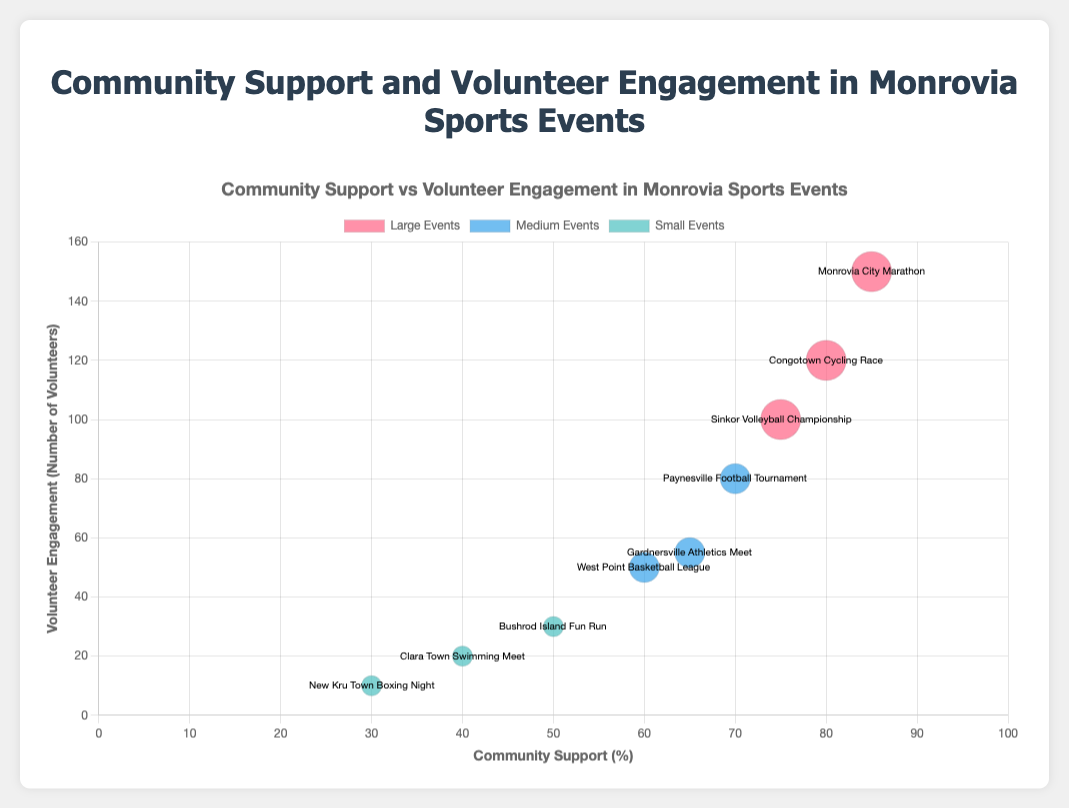What's the title of the figure? The title is at the top of the figure and reads "Community Support vs Volunteer Engagement in Monrovia Sports Events".
Answer: Community Support vs Volunteer Engagement in Monrovia Sports Events How many events are shown as large-sized bubbles in the chart? The large-sized events are represented by three bubbles labeled "Monrovia City Marathon", "Sinkor Volleyball Championship", and "Congotown Cycling Race".
Answer: 3 Which event has the highest community support percentage? By looking at the x-axis, the "Monrovia City Marathon" bubble is positioned the farthest to the right, indicating it has the highest community support percentage.
Answer: Monrovia City Marathon What is the volunteer engagement level for the "New Kru Town Boxing Night"? We can locate the "New Kru Town Boxing Night" bubble and observe the y-axis value corresponding to this bubble, which is 10.
Answer: 10 Among the medium-sized events, which one has the lowest community support percentage? In the medium-sized event group (blue bubbles), "West Point Basketball League" is the farthest to the left on the x-axis, indicating it has the lowest community support percentage.
Answer: West Point Basketball League What is the average community support percentage for all small events? The community support percentages for small events are 40, 50, and 30. The average is computed as (40 + 50 + 30) / 3 = 120 / 3.
Answer: 40 Which event has the largest volunteer engagement among the medium-sized events? By comparing the y-axis positions of the blue bubbles (medium-sized events), "Paynesville Football Tournament" is the highest, indicating it has the greatest volunteer engagement, which is 80.
Answer: Paynesville Football Tournament How does community support for the "Congotown Cycling Race" compare to the "Sinkor Volleyball Championship"? By comparing the x-axis positions of their respective bubbles, "Congotown Cycling Race" has a slightly higher x-axis value (community support) than "Sinkor Volleyball Championship".
Answer: Congotown Cycling Race What’s the difference in volunteer engagement between the "Bushrod Island Fun Run" and the "Clara Town Swimming Meet"? The volunteer engagement levels are 30 and 20 respectively. The difference is 30 - 20.
Answer: 10 Is there a correlation between event size and volunteer engagement based on the chart? By examining the chart, it appears that larger events (red bubbles) tend to have higher volunteer engagement compared to smaller and medium-sized events, suggesting a positive correlation.
Answer: Yes 